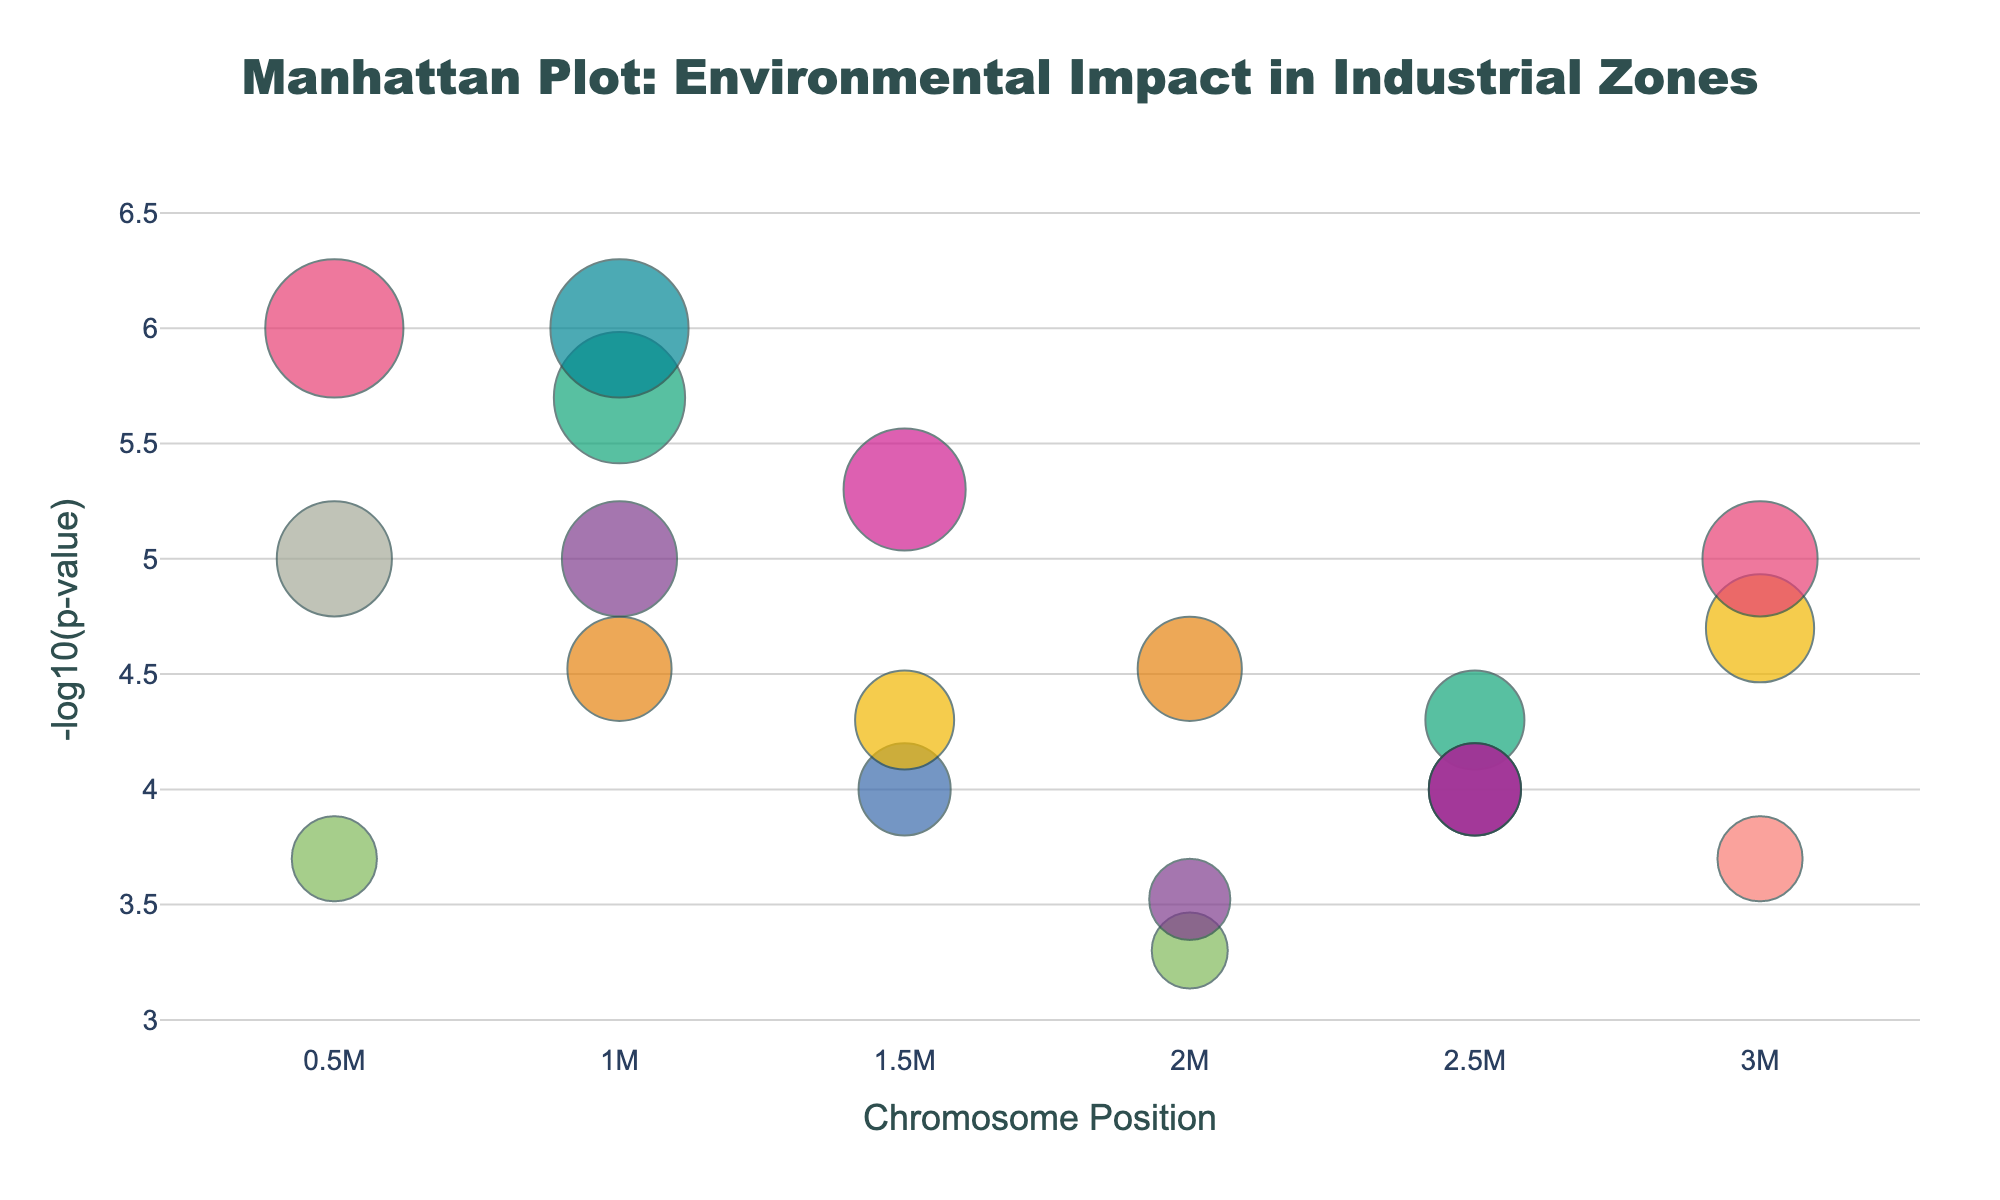What is the title of the plot? The plot's title is displayed at the top center and reads "Manhattan Plot: Environmental Impact in Industrial Zones."
Answer: Manhattan Plot: Environmental Impact in Industrial Zones What does the y-axis represent? The y-axis title is shown on the left side and reads "-log10(p-value)." It indicates the negative logarithm of the p-value of the pollutants.
Answer: -log10(p-value) How many chromosomes are represented in the plot? By observing the x-axis labels, we can see that there are markers for Chromosome 1 through Chromosome 10, indicating that 10 chromosomes are represented.
Answer: 10 Which pollutant has the lowest p-value, and on which chromosome is it located? The lowest p-value corresponds to the highest -log10(p) value. The highest point in the plot is for Ozone on Chromosome 3.
Answer: Ozone on Chromosome 3 What is the significance threshold and how is it indicated in the plot? The significance threshold is generally considered as p-value < 0.05, which is equivalent to -log10(p-value) > 1.3. In the plot, any points above y = 1.3 can be considered significant.
Answer: -log10(p) > 1.3 How many pollutants have p-values less than 0.0001? By looking at the y-axis values, we find the points with -log10(p) > 4 (since -log10(0.0001) = 4). The pollutants are PM2.5, Ozone, CO, Formaldehyde, Arsenic, Mercury, PAHs, and Black Carbon, a total of 8 pollutants.
Answer: 8 Which chromosome has the highest number of significant pollutants? Count the points above the significance threshold for each chromosome. Chromosome 1 has the most significant points with PM2.5 and NOx.
Answer: Chromosome 1 What is the position of Benzene on Chromosome 4 based on the plot? By looking at Chromosome 4 and identifying the point labeled Benzene, we see that its position is at 2,500,000.
Answer: 2,500,000 Which pollutant has the largest point size and what does it signify? The largest point indicates the smallest p-value. The pollutant with the largest point size is Ozone, signifying the highest -log10(p-value).
Answer: Ozone 